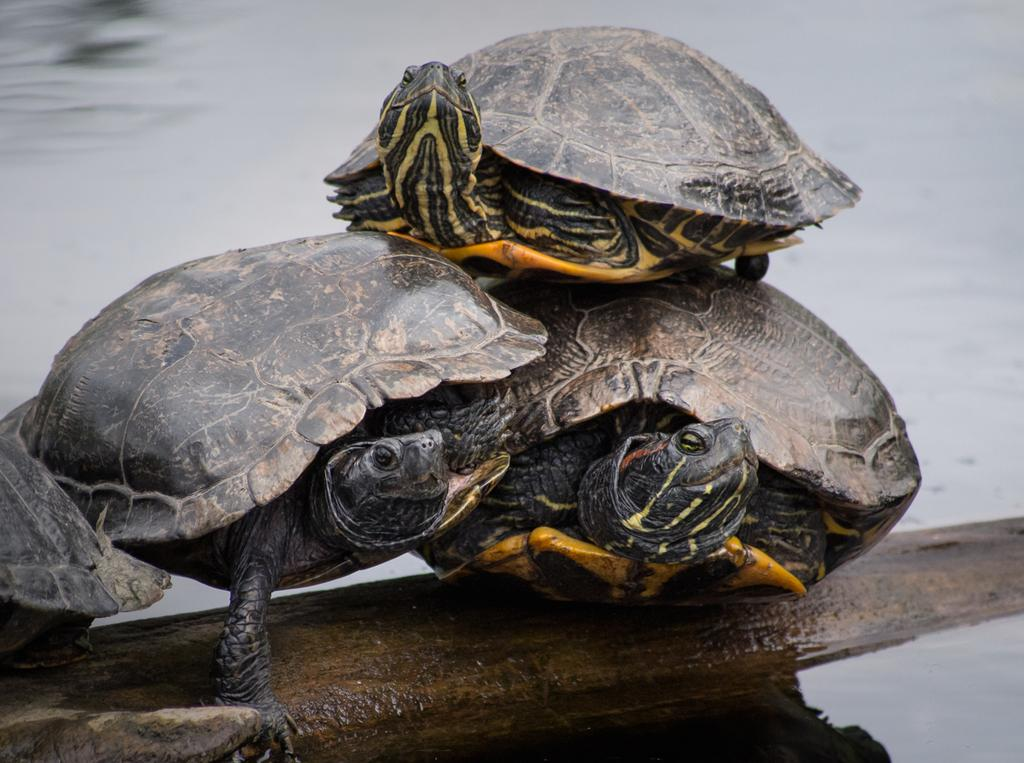What is the primary element in the picture? There is water in the picture. What type of animals can be seen in the water? There are tortoises in the water. What is visible at the bottom portion of the picture? There is a rock surface at the bottom portion of the picture. What type of brush is being used by the tortoises in the picture? There is no brush present in the image, and the tortoises are not using any tools or objects. 